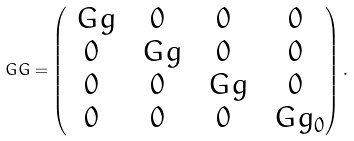Convert formula to latex. <formula><loc_0><loc_0><loc_500><loc_500>\ G G = \begin{pmatrix} \ G g & 0 & 0 & 0 \\ 0 & \ G g & 0 & 0 \\ 0 & 0 & \ G g & 0 \\ 0 & 0 & 0 & \ G g _ { 0 } \end{pmatrix} .</formula> 